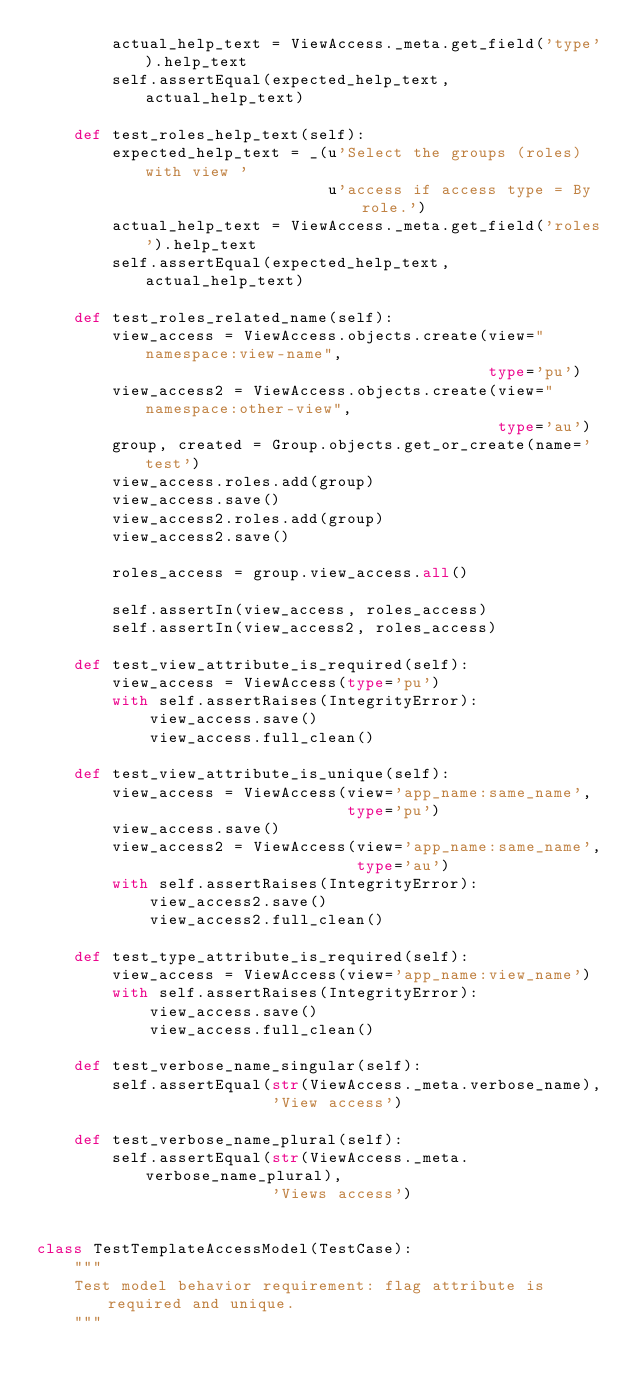Convert code to text. <code><loc_0><loc_0><loc_500><loc_500><_Python_>        actual_help_text = ViewAccess._meta.get_field('type').help_text
        self.assertEqual(expected_help_text, actual_help_text)

    def test_roles_help_text(self):
        expected_help_text = _(u'Select the groups (roles) with view '
                               u'access if access type = By role.')
        actual_help_text = ViewAccess._meta.get_field('roles').help_text
        self.assertEqual(expected_help_text, actual_help_text)

    def test_roles_related_name(self):
        view_access = ViewAccess.objects.create(view="namespace:view-name",
                                                type='pu')
        view_access2 = ViewAccess.objects.create(view="namespace:other-view",
                                                 type='au')
        group, created = Group.objects.get_or_create(name='test')
        view_access.roles.add(group)
        view_access.save()
        view_access2.roles.add(group)
        view_access2.save()

        roles_access = group.view_access.all()

        self.assertIn(view_access, roles_access)
        self.assertIn(view_access2, roles_access)

    def test_view_attribute_is_required(self):
        view_access = ViewAccess(type='pu')
        with self.assertRaises(IntegrityError):
            view_access.save()
            view_access.full_clean()

    def test_view_attribute_is_unique(self):
        view_access = ViewAccess(view='app_name:same_name',
                                 type='pu')
        view_access.save()
        view_access2 = ViewAccess(view='app_name:same_name',
                                  type='au')
        with self.assertRaises(IntegrityError):
            view_access2.save()
            view_access2.full_clean()

    def test_type_attribute_is_required(self):
        view_access = ViewAccess(view='app_name:view_name')
        with self.assertRaises(IntegrityError):
            view_access.save()
            view_access.full_clean()

    def test_verbose_name_singular(self):
        self.assertEqual(str(ViewAccess._meta.verbose_name),
                         'View access')

    def test_verbose_name_plural(self):
        self.assertEqual(str(ViewAccess._meta.verbose_name_plural),
                         'Views access')


class TestTemplateAccessModel(TestCase):
    """
    Test model behavior requirement: flag attribute is required and unique.
    """</code> 